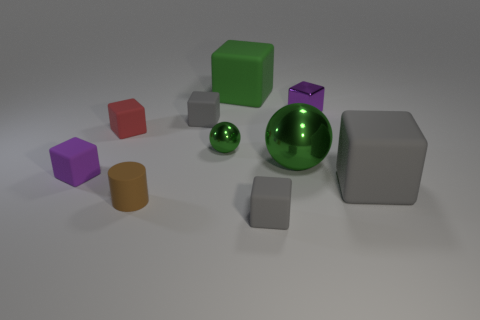Is the big ball the same color as the tiny metal ball?
Offer a very short reply. Yes. The large metal thing that is the same color as the tiny metallic ball is what shape?
Your answer should be compact. Sphere. There is a big green object in front of the purple cube that is to the right of the small brown object; what is it made of?
Ensure brevity in your answer.  Metal. Do the large green block that is right of the red object and the tiny cylinder have the same material?
Provide a short and direct response. Yes. There is a purple cube that is to the left of the big green cube; what is its size?
Give a very brief answer. Small. There is a purple cube in front of the tiny green shiny object; are there any shiny blocks that are in front of it?
Keep it short and to the point. No. There is a large block that is on the left side of the big metal ball; is its color the same as the tiny rubber cylinder left of the large green block?
Ensure brevity in your answer.  No. The small rubber cylinder is what color?
Make the answer very short. Brown. Is there any other thing that is the same color as the small sphere?
Give a very brief answer. Yes. There is a tiny rubber cube that is both on the right side of the small brown matte cylinder and behind the small brown matte object; what is its color?
Offer a terse response. Gray. 